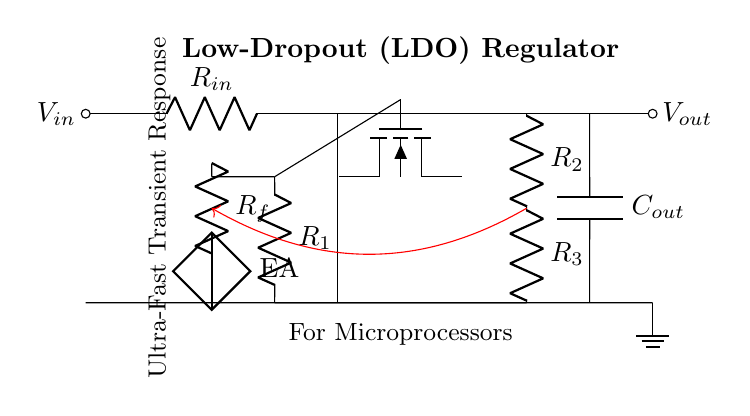What is the input voltage of the LDO regulator? The input voltage is denoted as \( V_{in} \), which is the voltage applied to the input of the circuit.
Answer: \( V_{in} \) What type of transistor is used in the LDO circuit? The circuit uses a PNP transistor, as indicated by the label "pnp" in the diagram.
Answer: PNP How many resistors are present in the feedback network? There are two resistors shown in the feedback network, labeled \( R_2 \) and \( R_3 \).
Answer: 2 What is the role of the component labeled as EA? The component labeled as EA refers to the error amplifier, which regulates the output voltage based on the feedback from the output.
Answer: Error amplifier What is the primary purpose of using a low-dropout regulator? The primary purpose is to maintain a regulated output voltage even when the input voltage is close to the output voltage, preserving efficiency.
Answer: Maintain regulated voltage Which component helps to smooth the output voltage? The capacitor labeled \( C_{out} \) is used to smooth the output voltage, reducing fluctuations and providing stability in the output.
Answer: Capacitor What might be the impact of an ultra-fast transient response in this circuit? An ultra-fast transient response allows the LDO to quickly adjust to changes in load conditions, ensuring stable operation for microprocessors.
Answer: Quick load adjustment 